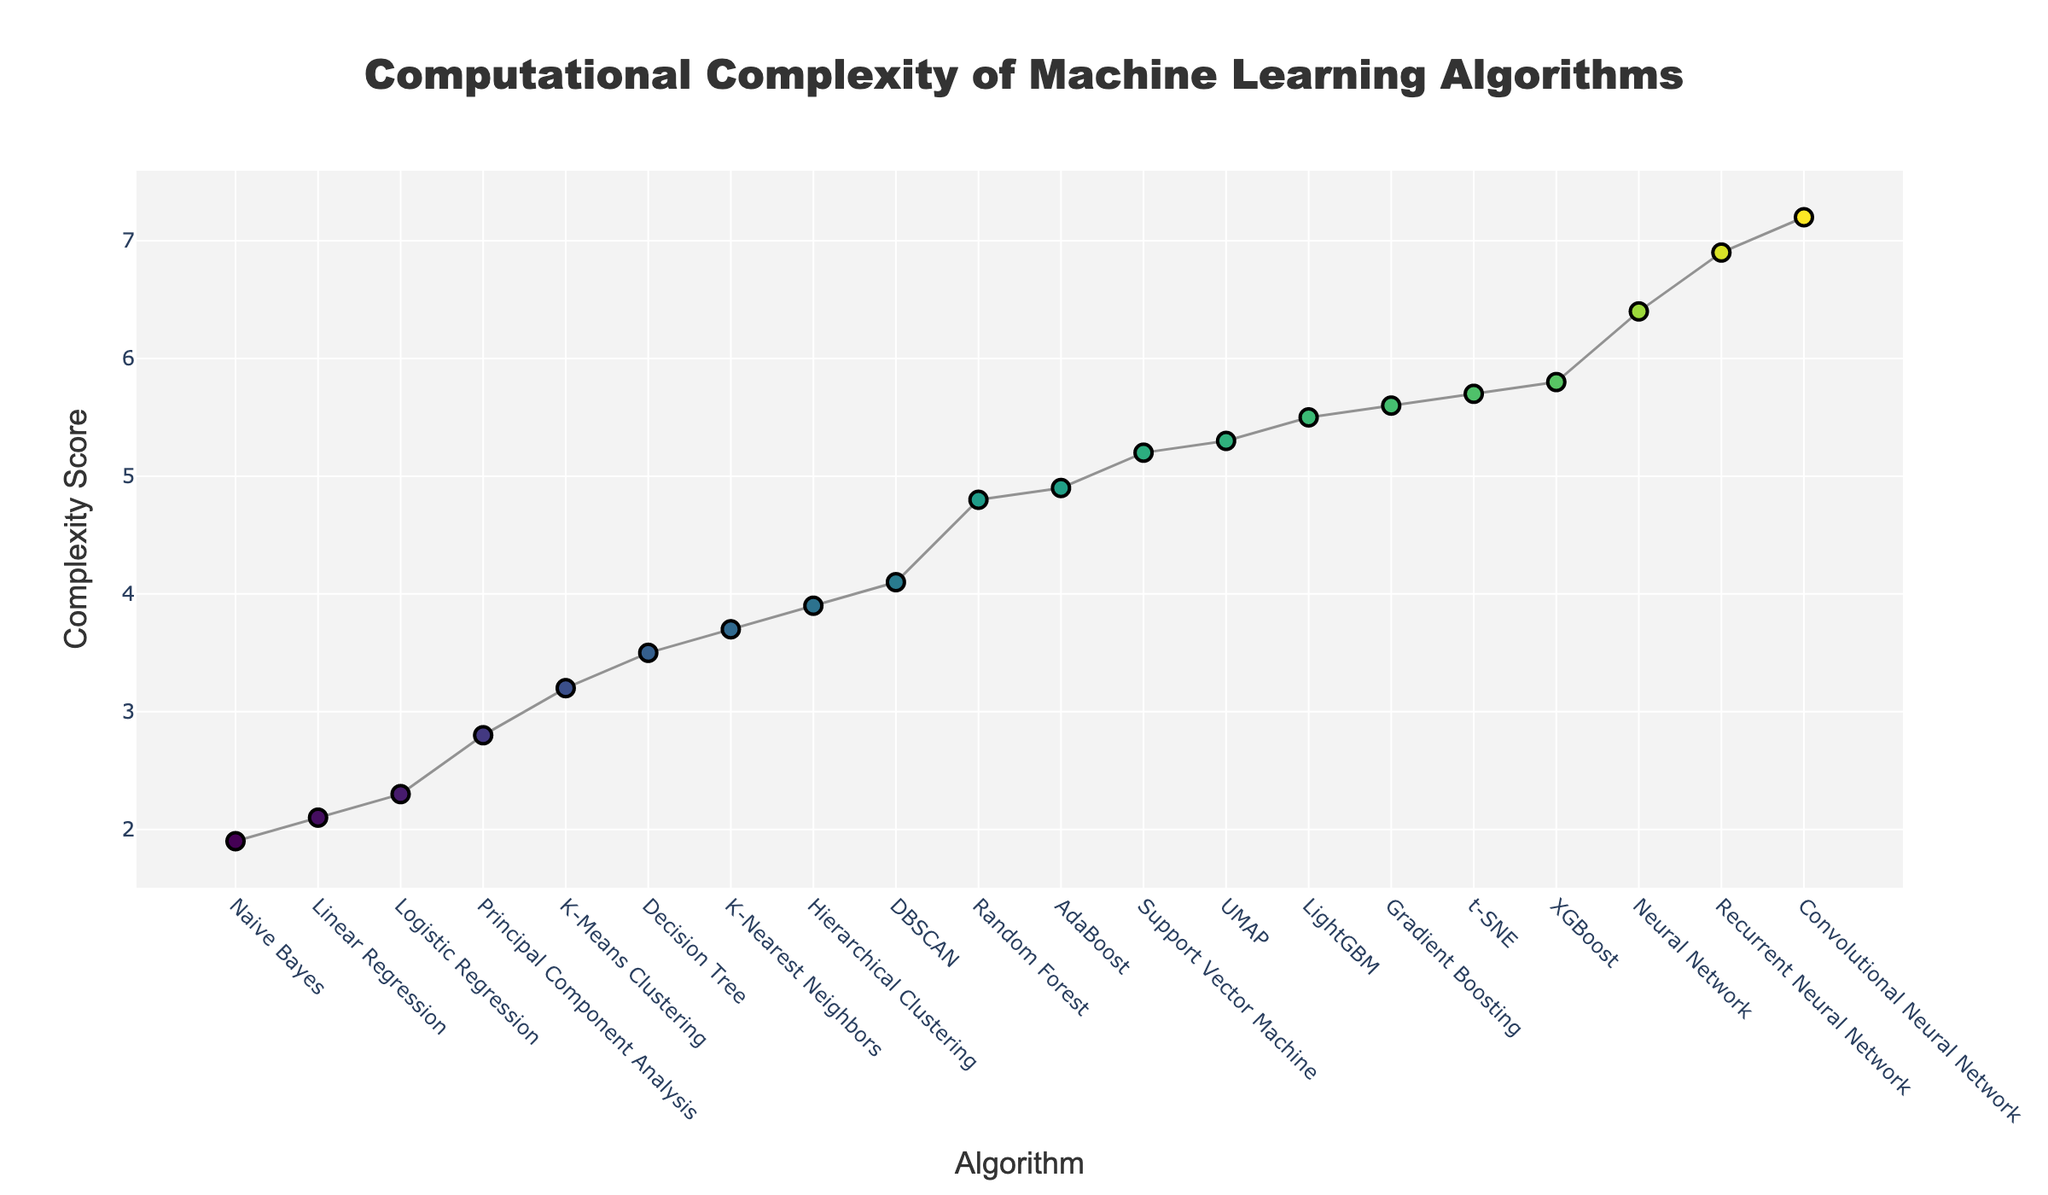What's the title of the figure? The title is at the top of the figure and is in a larger, bold font to draw attention to it. It reads, "Computational Complexity of Machine Learning Algorithms".
Answer: Computational Complexity of Machine Learning Algorithms What are the axes titles in this figure? The x-axis title is at the bottom of the horizontal axis and reads "Algorithm". The y-axis title is along the vertical axis and reads "Complexity Score".
Answer: Algorithm (x-axis), Complexity Score (y-axis) What is the complexity score of the Linear Regression algorithm? Locate the 'Linear Regression' data point on the x-axis and read the corresponding y-axis value. The plot shows this value as 2.1.
Answer: 2.1 Which algorithm has the highest complexity score? Identify the highest point on the plot, follow it to the corresponding x-axis label which is 'Convolutional Neural Network'. The y-axis value confirms the highest complexity score of 7.2.
Answer: Convolutional Neural Network How many algorithms have a complexity score higher than 5? Count the number of data points above the y-axis value of 5. The algorithms are Support Vector Machine, Neural Network, Gradient Boosting, t-SNE, UMAP, XGBoost, LightGBM, Convolutional Neural Network, and Recurrent Neural Network.
Answer: 9 What is the average complexity score of all algorithms? Sum all complexity scores and divide by the number of algorithms: (2.1 + 2.3 + 3.5 + 4.8 + 5.2 + 3.7 + 1.9 + 6.4 + 5.6 + 4.9 + 5.8 + 5.5 + 3.2 + 4.1 + 3.9 + 2.8 + 5.7 + 5.3 + 7.2 + 6.9) / 20. The total is 91.8, so the average is 91.8/20 = 4.59.
Answer: 4.59 Which two algorithms have the closest complexity scores, and what are their values? Look for data points that lie closest to each other on the y-axis. 'Logistic Regression' and 'Linear Regression' are very close with scores of 2.3 and 2.1 respectively.
Answer: Logistic Regression (2.3) and Linear Regression (2.1) By how much does the complexity score of Neural Network exceed that of Decision Tree? Subtract the complexity score of Decision Tree from that of Neural Network: 6.4 - 3.5 = 2.9.
Answer: 2.9 Which clustering algorithm has the lowest complexity score? Compare the complexity scores of 'K-Means Clustering', 'DBSCAN', and 'Hierarchical Clustering'. The lowest score is for K-Means Clustering at 3.2.
Answer: K-Means Clustering What is the median complexity score of the algorithms? Arrange all complexity scores in increasing order and find the middle value. With 20 algorithms, the median will be the average of the 10th and 11th values. The values are 4.8 and 4.9, so the median is (4.8 + 4.9) / 2 = 4.85.
Answer: 4.85 